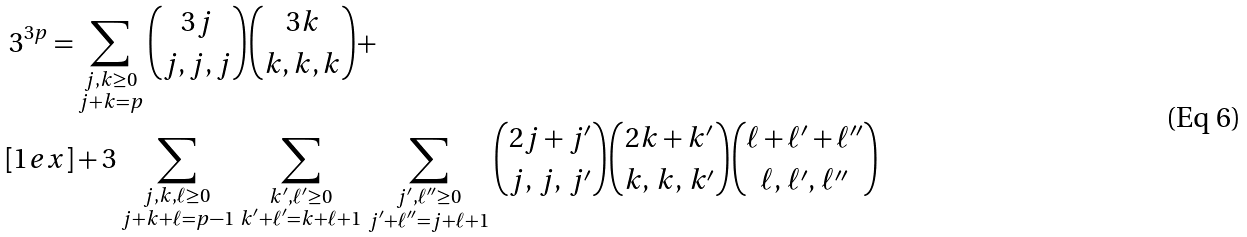Convert formula to latex. <formula><loc_0><loc_0><loc_500><loc_500>3 ^ { 3 p } = & \sum _ { \substack { j , k \geq 0 \\ j + k = p } } \binom { 3 j } { j , j , j } \binom { 3 k } { k , k , k } + \\ [ 1 e x ] & + 3 \sum _ { \substack { j , k , \ell \geq 0 \\ j + k + \ell = p - 1 } } \, \sum _ { \substack { k ^ { \prime } , \ell ^ { \prime } \geq 0 \\ k ^ { \prime } + \ell ^ { \prime } = k + \ell + 1 } } \, \sum _ { \substack { j ^ { \prime } , \ell ^ { \prime \prime } \geq 0 \\ j ^ { \prime } + \ell ^ { \prime \prime } = j + \ell + 1 } } \binom { 2 j + j ^ { \prime } } { j , \, j , \, j ^ { \prime } } \binom { 2 k + k ^ { \prime } } { k , \, k , \, k ^ { \prime } } \binom { \ell + \ell ^ { \prime } + \ell ^ { \prime \prime } } { \ell , \, \ell ^ { \prime } , \, \ell ^ { \prime \prime } }</formula> 